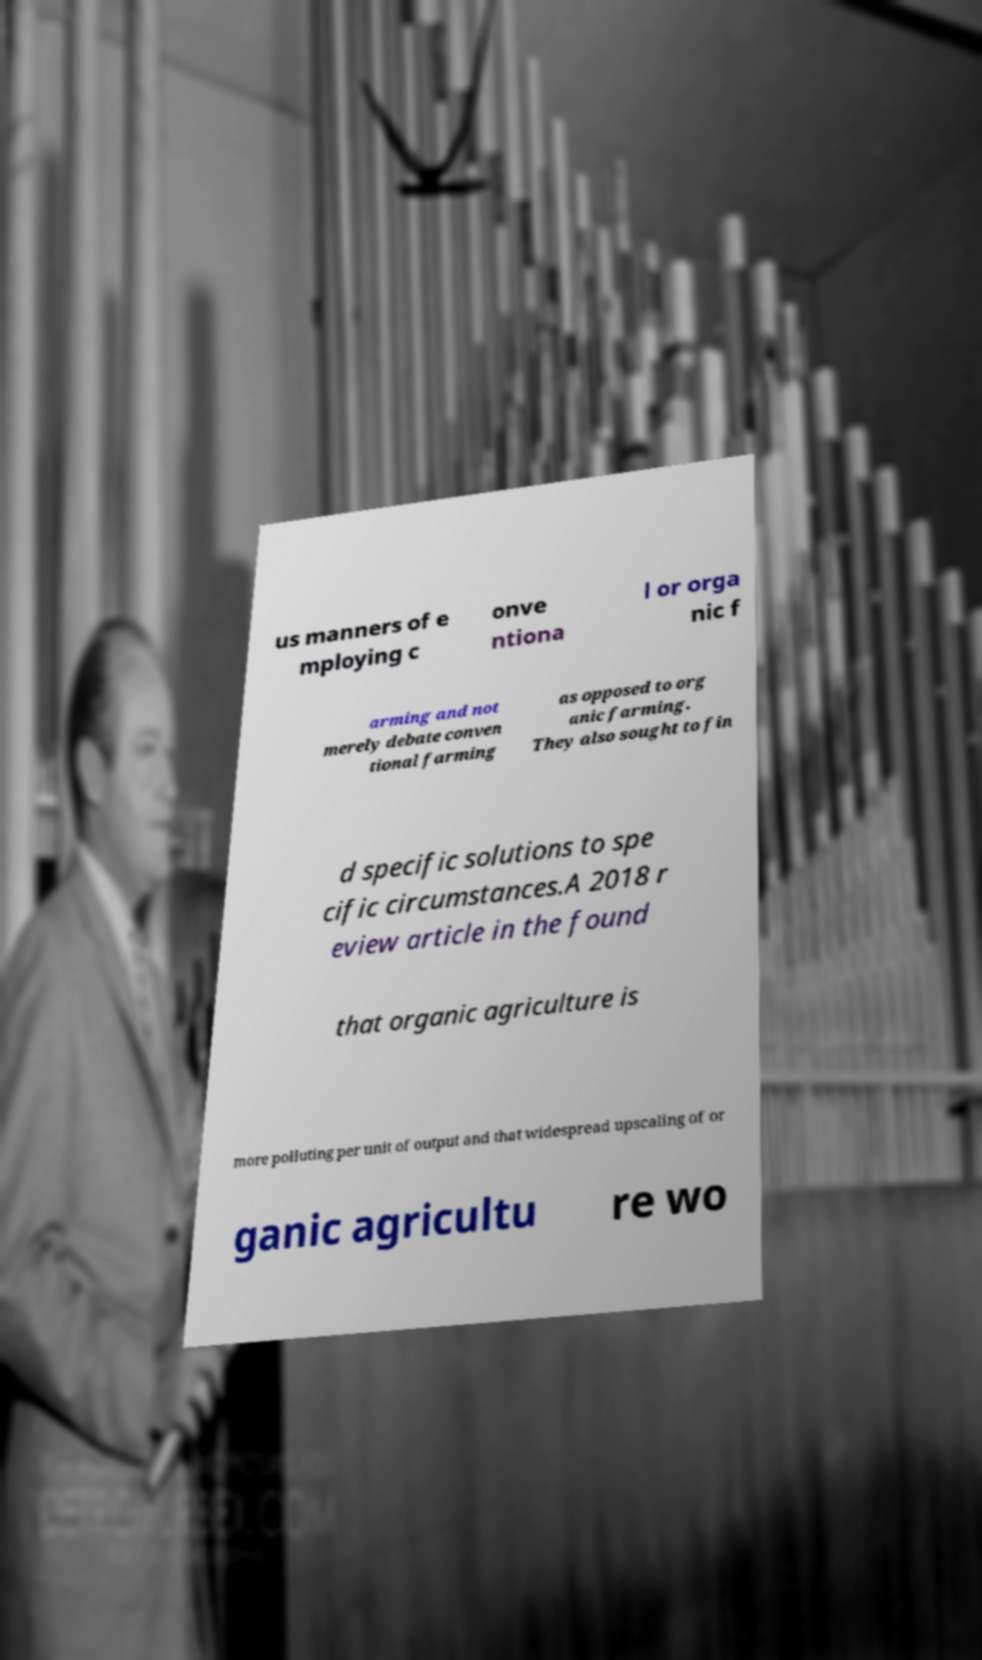Please identify and transcribe the text found in this image. us manners of e mploying c onve ntiona l or orga nic f arming and not merely debate conven tional farming as opposed to org anic farming. They also sought to fin d specific solutions to spe cific circumstances.A 2018 r eview article in the found that organic agriculture is more polluting per unit of output and that widespread upscaling of or ganic agricultu re wo 